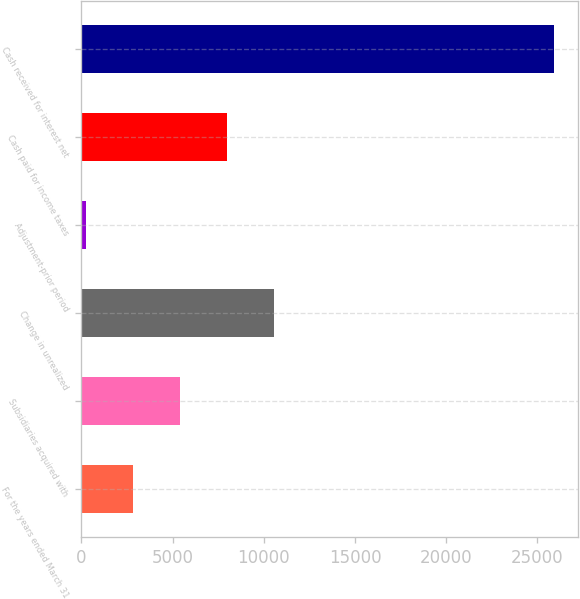Convert chart to OTSL. <chart><loc_0><loc_0><loc_500><loc_500><bar_chart><fcel>For the years ended March 31<fcel>Subsidiaries acquired with<fcel>Change in unrealized<fcel>Adjustment-prior period<fcel>Cash paid for income taxes<fcel>Cash received for interest net<nl><fcel>2825.2<fcel>5390.4<fcel>10576<fcel>260<fcel>7955.6<fcel>25912<nl></chart> 